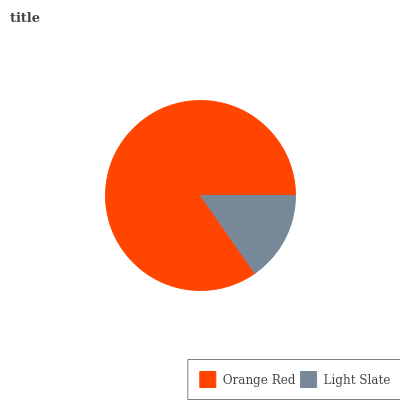Is Light Slate the minimum?
Answer yes or no. Yes. Is Orange Red the maximum?
Answer yes or no. Yes. Is Light Slate the maximum?
Answer yes or no. No. Is Orange Red greater than Light Slate?
Answer yes or no. Yes. Is Light Slate less than Orange Red?
Answer yes or no. Yes. Is Light Slate greater than Orange Red?
Answer yes or no. No. Is Orange Red less than Light Slate?
Answer yes or no. No. Is Orange Red the high median?
Answer yes or no. Yes. Is Light Slate the low median?
Answer yes or no. Yes. Is Light Slate the high median?
Answer yes or no. No. Is Orange Red the low median?
Answer yes or no. No. 